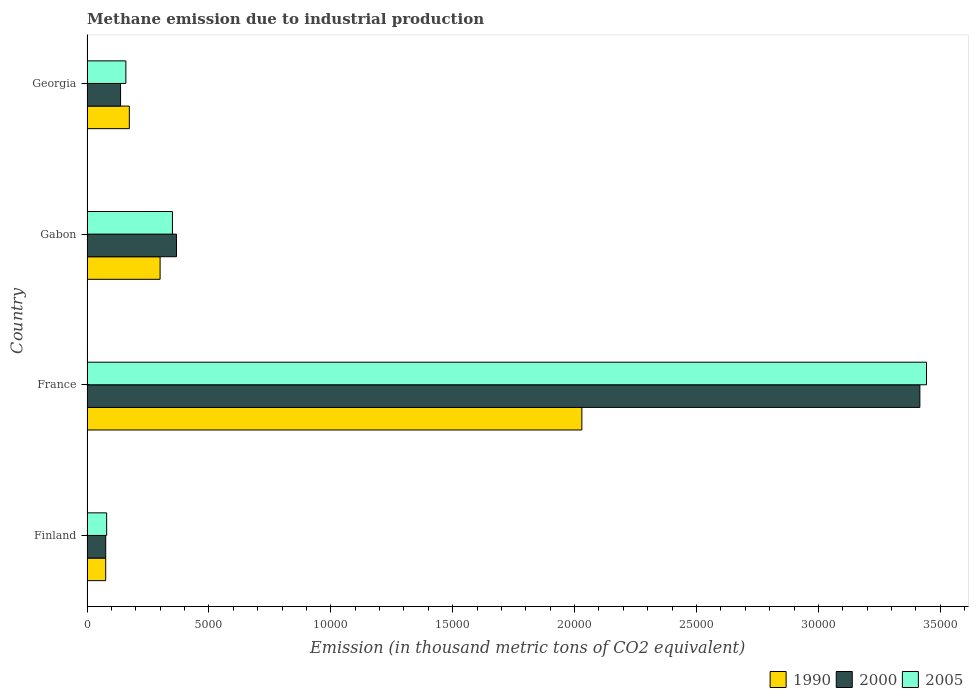Are the number of bars per tick equal to the number of legend labels?
Keep it short and to the point. Yes. In how many cases, is the number of bars for a given country not equal to the number of legend labels?
Your answer should be compact. 0. What is the amount of methane emitted in 2005 in France?
Keep it short and to the point. 3.44e+04. Across all countries, what is the maximum amount of methane emitted in 2000?
Offer a terse response. 3.42e+04. Across all countries, what is the minimum amount of methane emitted in 2000?
Your answer should be very brief. 767.8. In which country was the amount of methane emitted in 2005 minimum?
Your response must be concise. Finland. What is the total amount of methane emitted in 2005 in the graph?
Give a very brief answer. 4.03e+04. What is the difference between the amount of methane emitted in 1990 in Finland and that in Gabon?
Give a very brief answer. -2230.7. What is the difference between the amount of methane emitted in 2000 in Gabon and the amount of methane emitted in 2005 in Georgia?
Offer a terse response. 2076.4. What is the average amount of methane emitted in 1990 per country?
Provide a short and direct response. 6449.9. What is the difference between the amount of methane emitted in 2005 and amount of methane emitted in 1990 in Georgia?
Provide a succinct answer. -142.1. In how many countries, is the amount of methane emitted in 2000 greater than 20000 thousand metric tons?
Offer a very short reply. 1. What is the ratio of the amount of methane emitted in 2005 in Finland to that in France?
Ensure brevity in your answer.  0.02. What is the difference between the highest and the second highest amount of methane emitted in 2000?
Make the answer very short. 3.05e+04. What is the difference between the highest and the lowest amount of methane emitted in 2000?
Ensure brevity in your answer.  3.34e+04. In how many countries, is the amount of methane emitted in 2000 greater than the average amount of methane emitted in 2000 taken over all countries?
Offer a very short reply. 1. Is the sum of the amount of methane emitted in 1990 in France and Georgia greater than the maximum amount of methane emitted in 2005 across all countries?
Make the answer very short. No. Is it the case that in every country, the sum of the amount of methane emitted in 2005 and amount of methane emitted in 2000 is greater than the amount of methane emitted in 1990?
Your response must be concise. Yes. Are all the bars in the graph horizontal?
Provide a succinct answer. Yes. How many countries are there in the graph?
Provide a short and direct response. 4. What is the title of the graph?
Your answer should be compact. Methane emission due to industrial production. Does "1970" appear as one of the legend labels in the graph?
Make the answer very short. No. What is the label or title of the X-axis?
Provide a short and direct response. Emission (in thousand metric tons of CO2 equivalent). What is the Emission (in thousand metric tons of CO2 equivalent) in 1990 in Finland?
Your response must be concise. 767.5. What is the Emission (in thousand metric tons of CO2 equivalent) of 2000 in Finland?
Keep it short and to the point. 767.8. What is the Emission (in thousand metric tons of CO2 equivalent) in 2005 in Finland?
Your response must be concise. 806.6. What is the Emission (in thousand metric tons of CO2 equivalent) of 1990 in France?
Ensure brevity in your answer.  2.03e+04. What is the Emission (in thousand metric tons of CO2 equivalent) in 2000 in France?
Your answer should be very brief. 3.42e+04. What is the Emission (in thousand metric tons of CO2 equivalent) of 2005 in France?
Your answer should be very brief. 3.44e+04. What is the Emission (in thousand metric tons of CO2 equivalent) of 1990 in Gabon?
Offer a terse response. 2998.2. What is the Emission (in thousand metric tons of CO2 equivalent) in 2000 in Gabon?
Your answer should be compact. 3670.7. What is the Emission (in thousand metric tons of CO2 equivalent) in 2005 in Gabon?
Your answer should be compact. 3504.5. What is the Emission (in thousand metric tons of CO2 equivalent) in 1990 in Georgia?
Your answer should be compact. 1736.4. What is the Emission (in thousand metric tons of CO2 equivalent) of 2000 in Georgia?
Offer a terse response. 1376.9. What is the Emission (in thousand metric tons of CO2 equivalent) in 2005 in Georgia?
Offer a terse response. 1594.3. Across all countries, what is the maximum Emission (in thousand metric tons of CO2 equivalent) of 1990?
Ensure brevity in your answer.  2.03e+04. Across all countries, what is the maximum Emission (in thousand metric tons of CO2 equivalent) of 2000?
Provide a short and direct response. 3.42e+04. Across all countries, what is the maximum Emission (in thousand metric tons of CO2 equivalent) in 2005?
Ensure brevity in your answer.  3.44e+04. Across all countries, what is the minimum Emission (in thousand metric tons of CO2 equivalent) of 1990?
Offer a terse response. 767.5. Across all countries, what is the minimum Emission (in thousand metric tons of CO2 equivalent) in 2000?
Give a very brief answer. 767.8. Across all countries, what is the minimum Emission (in thousand metric tons of CO2 equivalent) in 2005?
Your answer should be very brief. 806.6. What is the total Emission (in thousand metric tons of CO2 equivalent) in 1990 in the graph?
Offer a very short reply. 2.58e+04. What is the total Emission (in thousand metric tons of CO2 equivalent) of 2000 in the graph?
Offer a terse response. 4.00e+04. What is the total Emission (in thousand metric tons of CO2 equivalent) of 2005 in the graph?
Your response must be concise. 4.03e+04. What is the difference between the Emission (in thousand metric tons of CO2 equivalent) of 1990 in Finland and that in France?
Keep it short and to the point. -1.95e+04. What is the difference between the Emission (in thousand metric tons of CO2 equivalent) of 2000 in Finland and that in France?
Keep it short and to the point. -3.34e+04. What is the difference between the Emission (in thousand metric tons of CO2 equivalent) of 2005 in Finland and that in France?
Keep it short and to the point. -3.36e+04. What is the difference between the Emission (in thousand metric tons of CO2 equivalent) in 1990 in Finland and that in Gabon?
Ensure brevity in your answer.  -2230.7. What is the difference between the Emission (in thousand metric tons of CO2 equivalent) of 2000 in Finland and that in Gabon?
Make the answer very short. -2902.9. What is the difference between the Emission (in thousand metric tons of CO2 equivalent) of 2005 in Finland and that in Gabon?
Keep it short and to the point. -2697.9. What is the difference between the Emission (in thousand metric tons of CO2 equivalent) in 1990 in Finland and that in Georgia?
Ensure brevity in your answer.  -968.9. What is the difference between the Emission (in thousand metric tons of CO2 equivalent) in 2000 in Finland and that in Georgia?
Your answer should be compact. -609.1. What is the difference between the Emission (in thousand metric tons of CO2 equivalent) in 2005 in Finland and that in Georgia?
Your answer should be compact. -787.7. What is the difference between the Emission (in thousand metric tons of CO2 equivalent) in 1990 in France and that in Gabon?
Give a very brief answer. 1.73e+04. What is the difference between the Emission (in thousand metric tons of CO2 equivalent) in 2000 in France and that in Gabon?
Your answer should be very brief. 3.05e+04. What is the difference between the Emission (in thousand metric tons of CO2 equivalent) in 2005 in France and that in Gabon?
Your response must be concise. 3.09e+04. What is the difference between the Emission (in thousand metric tons of CO2 equivalent) of 1990 in France and that in Georgia?
Provide a short and direct response. 1.86e+04. What is the difference between the Emission (in thousand metric tons of CO2 equivalent) in 2000 in France and that in Georgia?
Your answer should be compact. 3.28e+04. What is the difference between the Emission (in thousand metric tons of CO2 equivalent) of 2005 in France and that in Georgia?
Your answer should be very brief. 3.28e+04. What is the difference between the Emission (in thousand metric tons of CO2 equivalent) in 1990 in Gabon and that in Georgia?
Ensure brevity in your answer.  1261.8. What is the difference between the Emission (in thousand metric tons of CO2 equivalent) in 2000 in Gabon and that in Georgia?
Ensure brevity in your answer.  2293.8. What is the difference between the Emission (in thousand metric tons of CO2 equivalent) in 2005 in Gabon and that in Georgia?
Give a very brief answer. 1910.2. What is the difference between the Emission (in thousand metric tons of CO2 equivalent) in 1990 in Finland and the Emission (in thousand metric tons of CO2 equivalent) in 2000 in France?
Your answer should be very brief. -3.34e+04. What is the difference between the Emission (in thousand metric tons of CO2 equivalent) in 1990 in Finland and the Emission (in thousand metric tons of CO2 equivalent) in 2005 in France?
Ensure brevity in your answer.  -3.37e+04. What is the difference between the Emission (in thousand metric tons of CO2 equivalent) of 2000 in Finland and the Emission (in thousand metric tons of CO2 equivalent) of 2005 in France?
Your answer should be compact. -3.37e+04. What is the difference between the Emission (in thousand metric tons of CO2 equivalent) in 1990 in Finland and the Emission (in thousand metric tons of CO2 equivalent) in 2000 in Gabon?
Give a very brief answer. -2903.2. What is the difference between the Emission (in thousand metric tons of CO2 equivalent) of 1990 in Finland and the Emission (in thousand metric tons of CO2 equivalent) of 2005 in Gabon?
Provide a short and direct response. -2737. What is the difference between the Emission (in thousand metric tons of CO2 equivalent) in 2000 in Finland and the Emission (in thousand metric tons of CO2 equivalent) in 2005 in Gabon?
Give a very brief answer. -2736.7. What is the difference between the Emission (in thousand metric tons of CO2 equivalent) of 1990 in Finland and the Emission (in thousand metric tons of CO2 equivalent) of 2000 in Georgia?
Your response must be concise. -609.4. What is the difference between the Emission (in thousand metric tons of CO2 equivalent) of 1990 in Finland and the Emission (in thousand metric tons of CO2 equivalent) of 2005 in Georgia?
Give a very brief answer. -826.8. What is the difference between the Emission (in thousand metric tons of CO2 equivalent) of 2000 in Finland and the Emission (in thousand metric tons of CO2 equivalent) of 2005 in Georgia?
Offer a terse response. -826.5. What is the difference between the Emission (in thousand metric tons of CO2 equivalent) in 1990 in France and the Emission (in thousand metric tons of CO2 equivalent) in 2000 in Gabon?
Your answer should be compact. 1.66e+04. What is the difference between the Emission (in thousand metric tons of CO2 equivalent) in 1990 in France and the Emission (in thousand metric tons of CO2 equivalent) in 2005 in Gabon?
Keep it short and to the point. 1.68e+04. What is the difference between the Emission (in thousand metric tons of CO2 equivalent) in 2000 in France and the Emission (in thousand metric tons of CO2 equivalent) in 2005 in Gabon?
Provide a succinct answer. 3.07e+04. What is the difference between the Emission (in thousand metric tons of CO2 equivalent) in 1990 in France and the Emission (in thousand metric tons of CO2 equivalent) in 2000 in Georgia?
Ensure brevity in your answer.  1.89e+04. What is the difference between the Emission (in thousand metric tons of CO2 equivalent) of 1990 in France and the Emission (in thousand metric tons of CO2 equivalent) of 2005 in Georgia?
Your response must be concise. 1.87e+04. What is the difference between the Emission (in thousand metric tons of CO2 equivalent) of 2000 in France and the Emission (in thousand metric tons of CO2 equivalent) of 2005 in Georgia?
Your response must be concise. 3.26e+04. What is the difference between the Emission (in thousand metric tons of CO2 equivalent) in 1990 in Gabon and the Emission (in thousand metric tons of CO2 equivalent) in 2000 in Georgia?
Provide a succinct answer. 1621.3. What is the difference between the Emission (in thousand metric tons of CO2 equivalent) in 1990 in Gabon and the Emission (in thousand metric tons of CO2 equivalent) in 2005 in Georgia?
Offer a terse response. 1403.9. What is the difference between the Emission (in thousand metric tons of CO2 equivalent) in 2000 in Gabon and the Emission (in thousand metric tons of CO2 equivalent) in 2005 in Georgia?
Your answer should be very brief. 2076.4. What is the average Emission (in thousand metric tons of CO2 equivalent) of 1990 per country?
Offer a terse response. 6449.9. What is the average Emission (in thousand metric tons of CO2 equivalent) in 2000 per country?
Offer a very short reply. 9994.42. What is the average Emission (in thousand metric tons of CO2 equivalent) of 2005 per country?
Offer a terse response. 1.01e+04. What is the difference between the Emission (in thousand metric tons of CO2 equivalent) in 1990 and Emission (in thousand metric tons of CO2 equivalent) in 2000 in Finland?
Your response must be concise. -0.3. What is the difference between the Emission (in thousand metric tons of CO2 equivalent) in 1990 and Emission (in thousand metric tons of CO2 equivalent) in 2005 in Finland?
Provide a short and direct response. -39.1. What is the difference between the Emission (in thousand metric tons of CO2 equivalent) in 2000 and Emission (in thousand metric tons of CO2 equivalent) in 2005 in Finland?
Offer a very short reply. -38.8. What is the difference between the Emission (in thousand metric tons of CO2 equivalent) of 1990 and Emission (in thousand metric tons of CO2 equivalent) of 2000 in France?
Offer a very short reply. -1.39e+04. What is the difference between the Emission (in thousand metric tons of CO2 equivalent) in 1990 and Emission (in thousand metric tons of CO2 equivalent) in 2005 in France?
Provide a short and direct response. -1.41e+04. What is the difference between the Emission (in thousand metric tons of CO2 equivalent) in 2000 and Emission (in thousand metric tons of CO2 equivalent) in 2005 in France?
Make the answer very short. -272.3. What is the difference between the Emission (in thousand metric tons of CO2 equivalent) in 1990 and Emission (in thousand metric tons of CO2 equivalent) in 2000 in Gabon?
Give a very brief answer. -672.5. What is the difference between the Emission (in thousand metric tons of CO2 equivalent) in 1990 and Emission (in thousand metric tons of CO2 equivalent) in 2005 in Gabon?
Offer a very short reply. -506.3. What is the difference between the Emission (in thousand metric tons of CO2 equivalent) in 2000 and Emission (in thousand metric tons of CO2 equivalent) in 2005 in Gabon?
Your response must be concise. 166.2. What is the difference between the Emission (in thousand metric tons of CO2 equivalent) in 1990 and Emission (in thousand metric tons of CO2 equivalent) in 2000 in Georgia?
Make the answer very short. 359.5. What is the difference between the Emission (in thousand metric tons of CO2 equivalent) of 1990 and Emission (in thousand metric tons of CO2 equivalent) of 2005 in Georgia?
Offer a terse response. 142.1. What is the difference between the Emission (in thousand metric tons of CO2 equivalent) of 2000 and Emission (in thousand metric tons of CO2 equivalent) of 2005 in Georgia?
Ensure brevity in your answer.  -217.4. What is the ratio of the Emission (in thousand metric tons of CO2 equivalent) of 1990 in Finland to that in France?
Offer a very short reply. 0.04. What is the ratio of the Emission (in thousand metric tons of CO2 equivalent) of 2000 in Finland to that in France?
Your response must be concise. 0.02. What is the ratio of the Emission (in thousand metric tons of CO2 equivalent) of 2005 in Finland to that in France?
Your answer should be very brief. 0.02. What is the ratio of the Emission (in thousand metric tons of CO2 equivalent) in 1990 in Finland to that in Gabon?
Ensure brevity in your answer.  0.26. What is the ratio of the Emission (in thousand metric tons of CO2 equivalent) in 2000 in Finland to that in Gabon?
Give a very brief answer. 0.21. What is the ratio of the Emission (in thousand metric tons of CO2 equivalent) of 2005 in Finland to that in Gabon?
Your answer should be very brief. 0.23. What is the ratio of the Emission (in thousand metric tons of CO2 equivalent) of 1990 in Finland to that in Georgia?
Your answer should be very brief. 0.44. What is the ratio of the Emission (in thousand metric tons of CO2 equivalent) in 2000 in Finland to that in Georgia?
Your answer should be very brief. 0.56. What is the ratio of the Emission (in thousand metric tons of CO2 equivalent) of 2005 in Finland to that in Georgia?
Your response must be concise. 0.51. What is the ratio of the Emission (in thousand metric tons of CO2 equivalent) in 1990 in France to that in Gabon?
Your answer should be compact. 6.77. What is the ratio of the Emission (in thousand metric tons of CO2 equivalent) in 2000 in France to that in Gabon?
Your response must be concise. 9.31. What is the ratio of the Emission (in thousand metric tons of CO2 equivalent) in 2005 in France to that in Gabon?
Keep it short and to the point. 9.83. What is the ratio of the Emission (in thousand metric tons of CO2 equivalent) in 1990 in France to that in Georgia?
Ensure brevity in your answer.  11.69. What is the ratio of the Emission (in thousand metric tons of CO2 equivalent) in 2000 in France to that in Georgia?
Offer a very short reply. 24.81. What is the ratio of the Emission (in thousand metric tons of CO2 equivalent) of 2005 in France to that in Georgia?
Give a very brief answer. 21.6. What is the ratio of the Emission (in thousand metric tons of CO2 equivalent) of 1990 in Gabon to that in Georgia?
Make the answer very short. 1.73. What is the ratio of the Emission (in thousand metric tons of CO2 equivalent) in 2000 in Gabon to that in Georgia?
Offer a very short reply. 2.67. What is the ratio of the Emission (in thousand metric tons of CO2 equivalent) of 2005 in Gabon to that in Georgia?
Ensure brevity in your answer.  2.2. What is the difference between the highest and the second highest Emission (in thousand metric tons of CO2 equivalent) of 1990?
Provide a short and direct response. 1.73e+04. What is the difference between the highest and the second highest Emission (in thousand metric tons of CO2 equivalent) of 2000?
Offer a very short reply. 3.05e+04. What is the difference between the highest and the second highest Emission (in thousand metric tons of CO2 equivalent) in 2005?
Provide a succinct answer. 3.09e+04. What is the difference between the highest and the lowest Emission (in thousand metric tons of CO2 equivalent) of 1990?
Your response must be concise. 1.95e+04. What is the difference between the highest and the lowest Emission (in thousand metric tons of CO2 equivalent) of 2000?
Provide a succinct answer. 3.34e+04. What is the difference between the highest and the lowest Emission (in thousand metric tons of CO2 equivalent) of 2005?
Your response must be concise. 3.36e+04. 